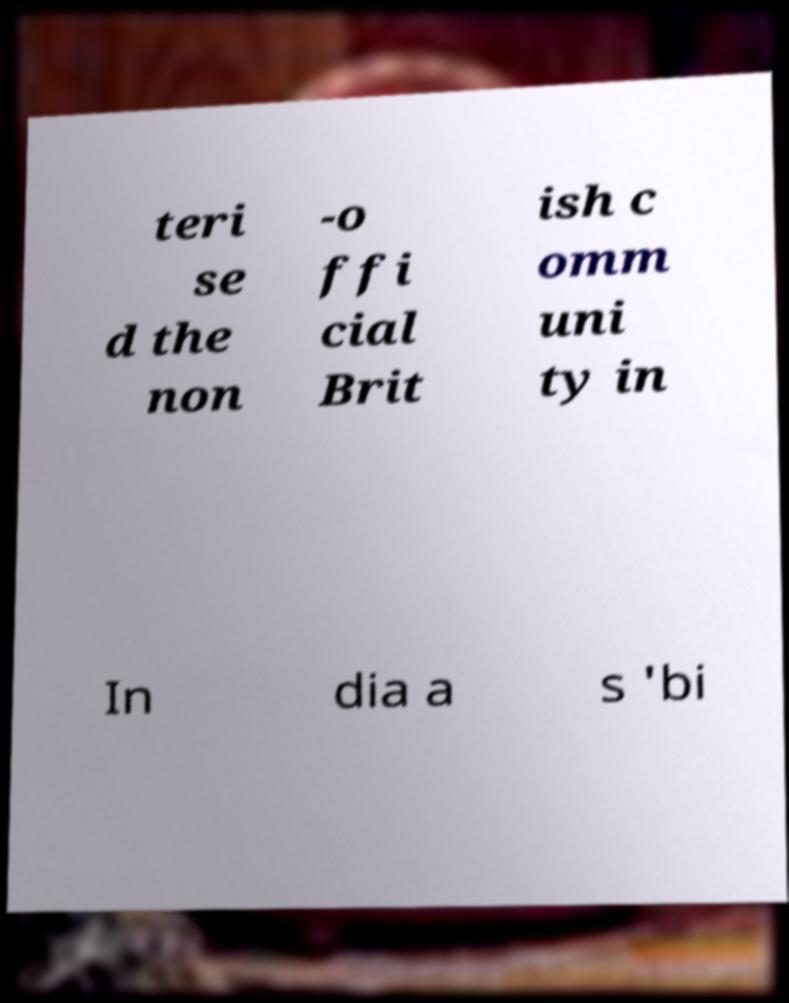Could you assist in decoding the text presented in this image and type it out clearly? teri se d the non -o ffi cial Brit ish c omm uni ty in In dia a s 'bi 